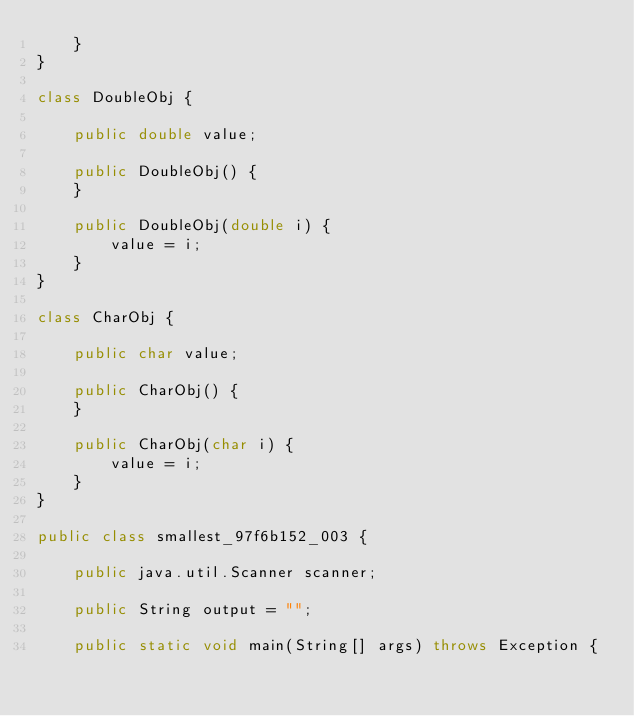Convert code to text. <code><loc_0><loc_0><loc_500><loc_500><_Java_>    }
}

class DoubleObj {

    public double value;

    public DoubleObj() {
    }

    public DoubleObj(double i) {
        value = i;
    }
}

class CharObj {

    public char value;

    public CharObj() {
    }

    public CharObj(char i) {
        value = i;
    }
}

public class smallest_97f6b152_003 {

    public java.util.Scanner scanner;

    public String output = "";

    public static void main(String[] args) throws Exception {</code> 